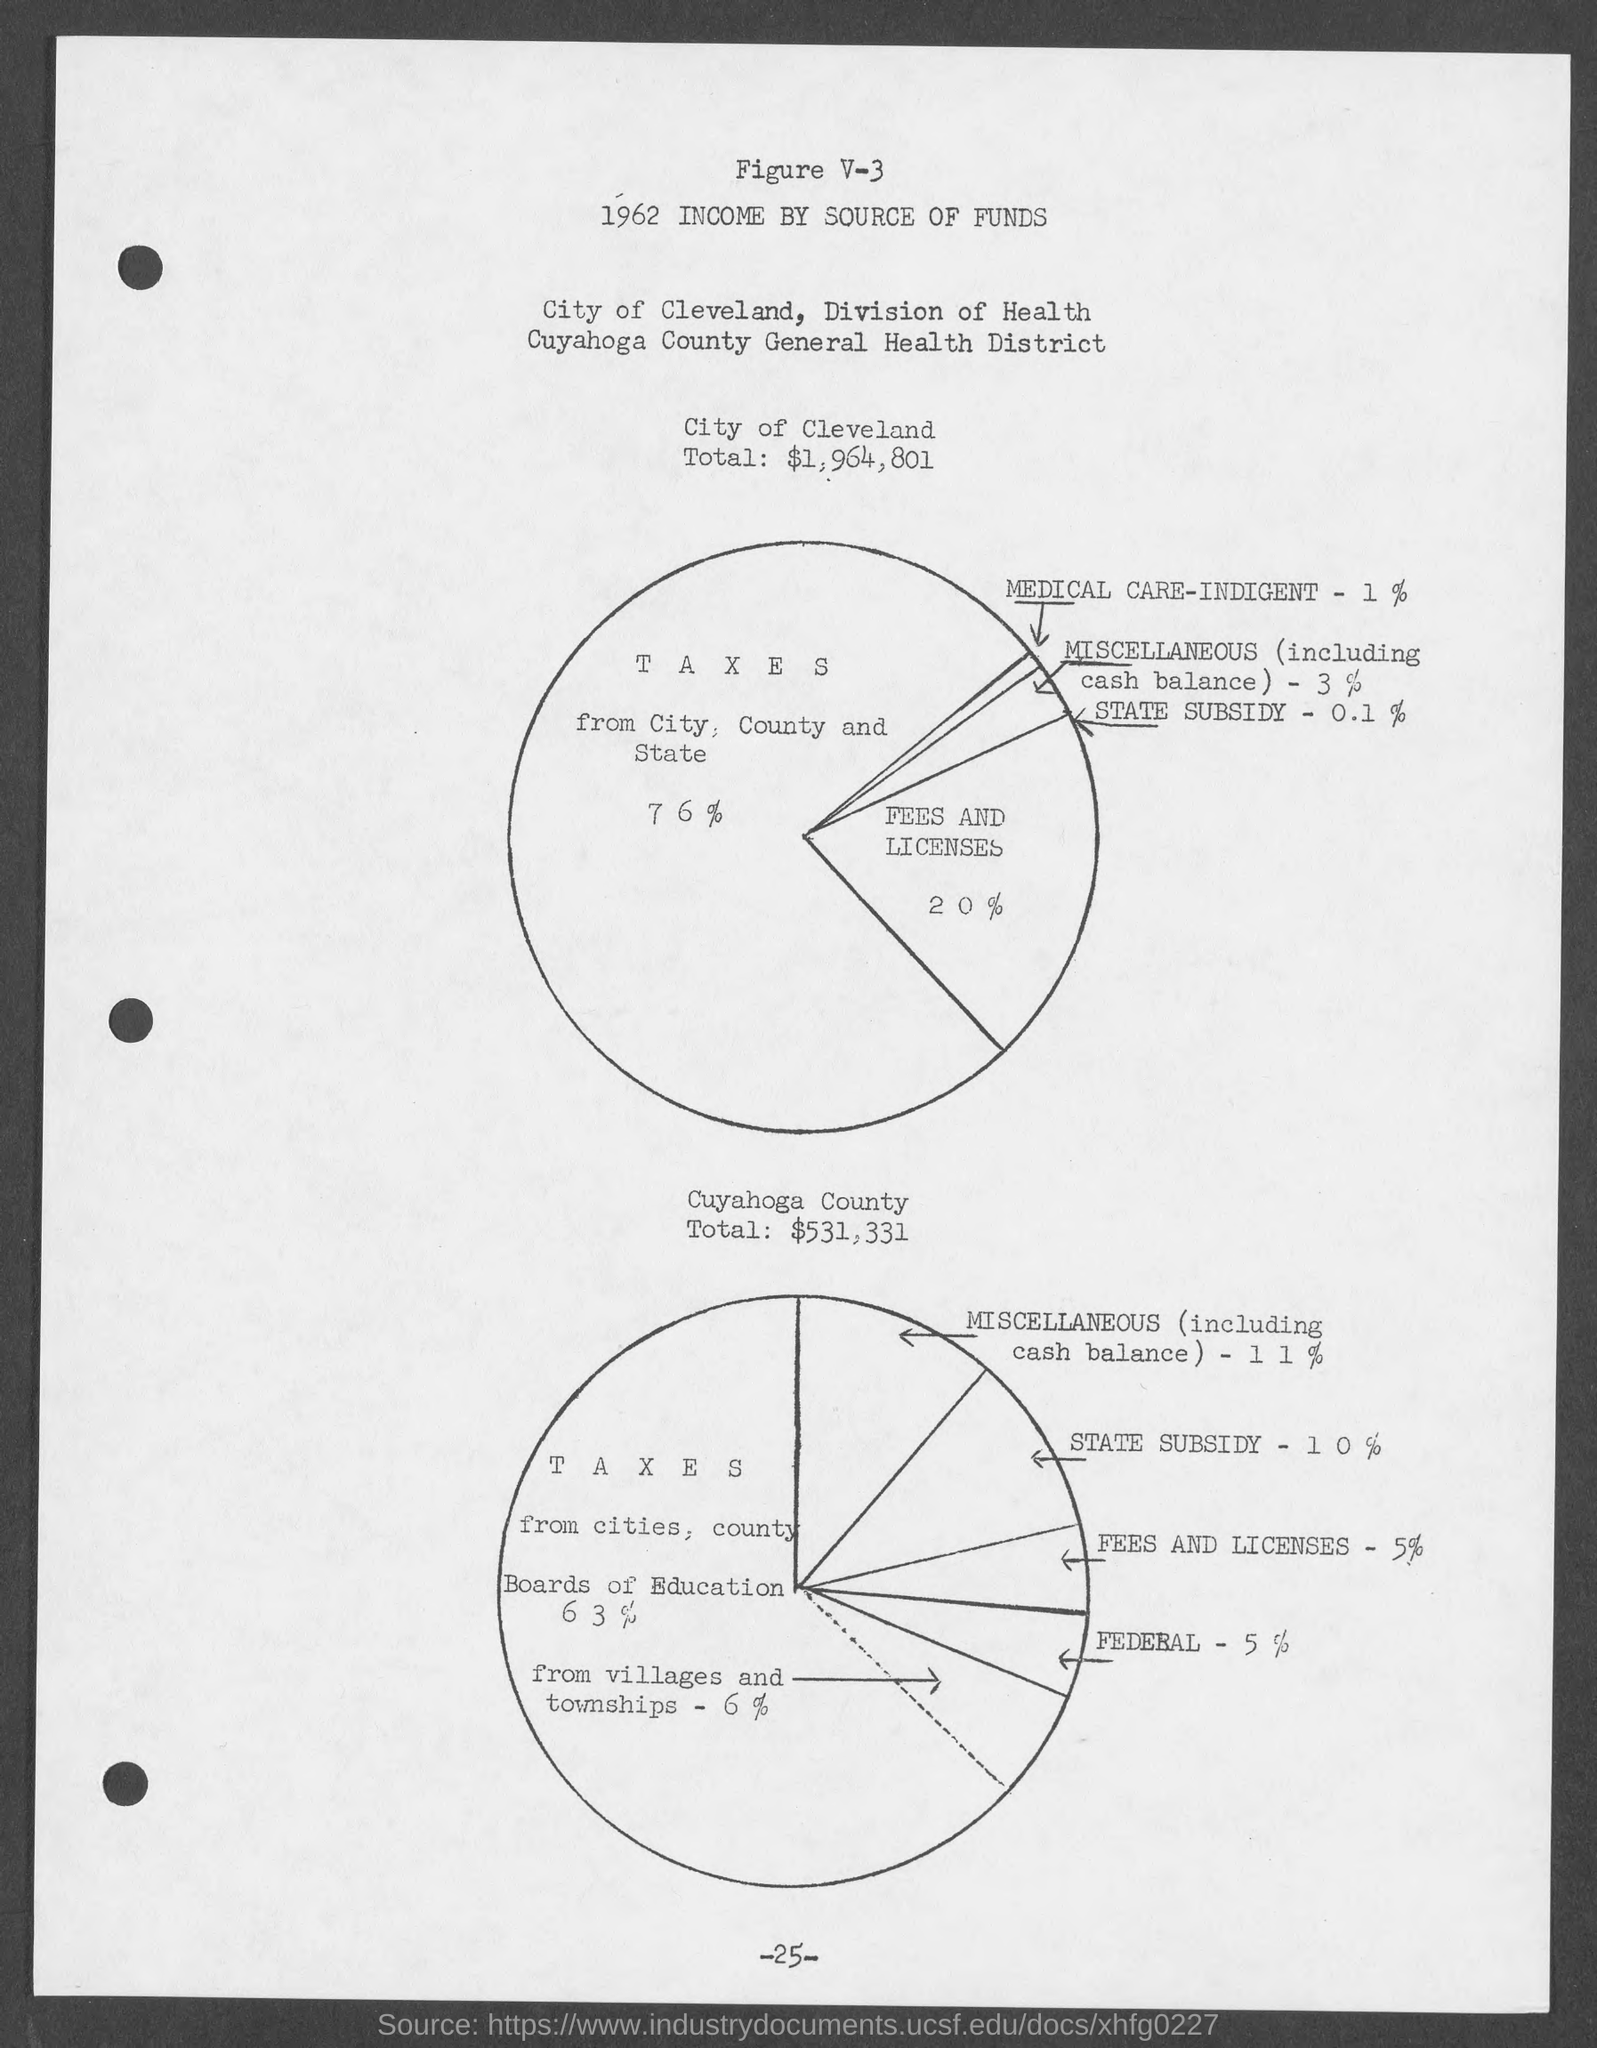Point out several critical features in this image. The number at the bottom of the page is -25. The total for Cuyahoga County is $531,331. The city of Cleveland's total is $1,964,801. 